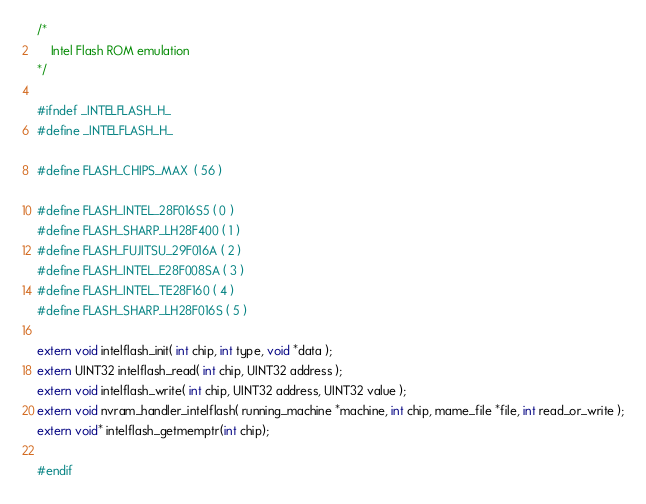<code> <loc_0><loc_0><loc_500><loc_500><_C_>/*
    Intel Flash ROM emulation
*/

#ifndef _INTELFLASH_H_
#define _INTELFLASH_H_

#define FLASH_CHIPS_MAX	( 56 )

#define FLASH_INTEL_28F016S5 ( 0 )
#define FLASH_SHARP_LH28F400 ( 1 )
#define FLASH_FUJITSU_29F016A ( 2 )
#define FLASH_INTEL_E28F008SA ( 3 )
#define FLASH_INTEL_TE28F160 ( 4 )
#define FLASH_SHARP_LH28F016S ( 5 )

extern void intelflash_init( int chip, int type, void *data );
extern UINT32 intelflash_read( int chip, UINT32 address );
extern void intelflash_write( int chip, UINT32 address, UINT32 value );
extern void nvram_handler_intelflash( running_machine *machine, int chip, mame_file *file, int read_or_write );
extern void* intelflash_getmemptr(int chip);

#endif
</code> 